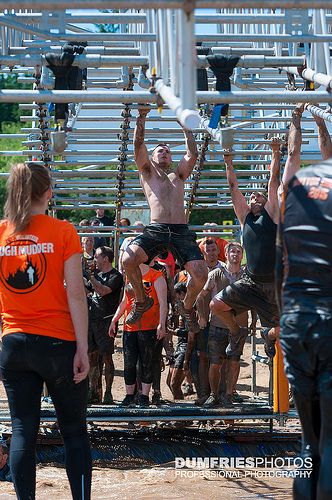<image>
Can you confirm if the stage is under the man? Yes. The stage is positioned underneath the man, with the man above it in the vertical space. Where is the man in relation to the woman? Is it next to the woman? No. The man is not positioned next to the woman. They are located in different areas of the scene. 